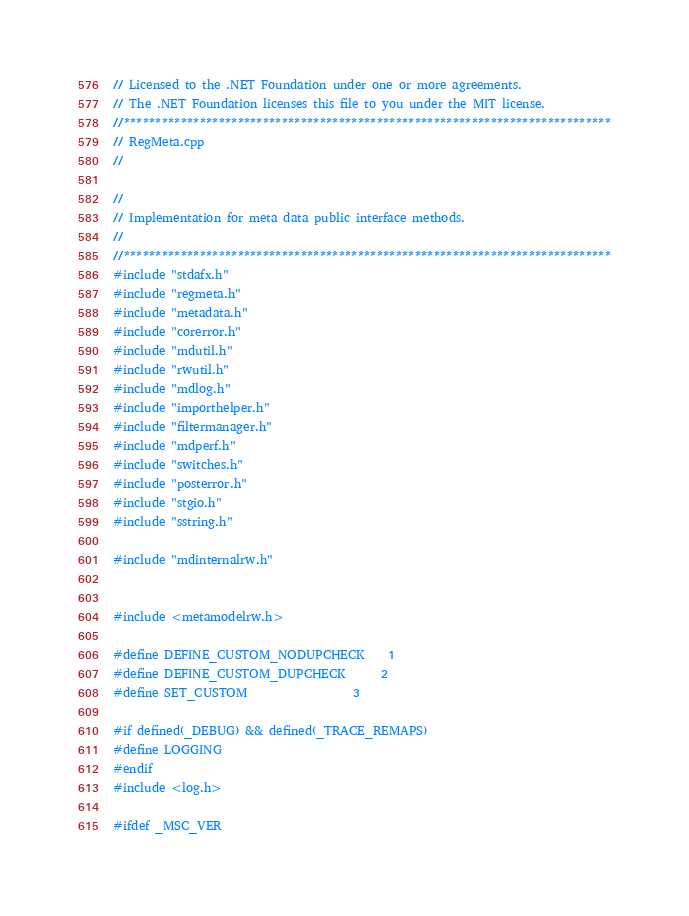Convert code to text. <code><loc_0><loc_0><loc_500><loc_500><_C++_>// Licensed to the .NET Foundation under one or more agreements.
// The .NET Foundation licenses this file to you under the MIT license.
//*****************************************************************************
// RegMeta.cpp
//

//
// Implementation for meta data public interface methods.
//
//*****************************************************************************
#include "stdafx.h"
#include "regmeta.h"
#include "metadata.h"
#include "corerror.h"
#include "mdutil.h"
#include "rwutil.h"
#include "mdlog.h"
#include "importhelper.h"
#include "filtermanager.h"
#include "mdperf.h"
#include "switches.h"
#include "posterror.h"
#include "stgio.h"
#include "sstring.h"

#include "mdinternalrw.h"


#include <metamodelrw.h>

#define DEFINE_CUSTOM_NODUPCHECK    1
#define DEFINE_CUSTOM_DUPCHECK      2
#define SET_CUSTOM                  3

#if defined(_DEBUG) && defined(_TRACE_REMAPS)
#define LOGGING
#endif
#include <log.h>

#ifdef _MSC_VER</code> 